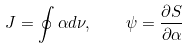<formula> <loc_0><loc_0><loc_500><loc_500>J = \oint \alpha d \nu , \quad \psi = \frac { \partial S } { \partial \alpha }</formula> 